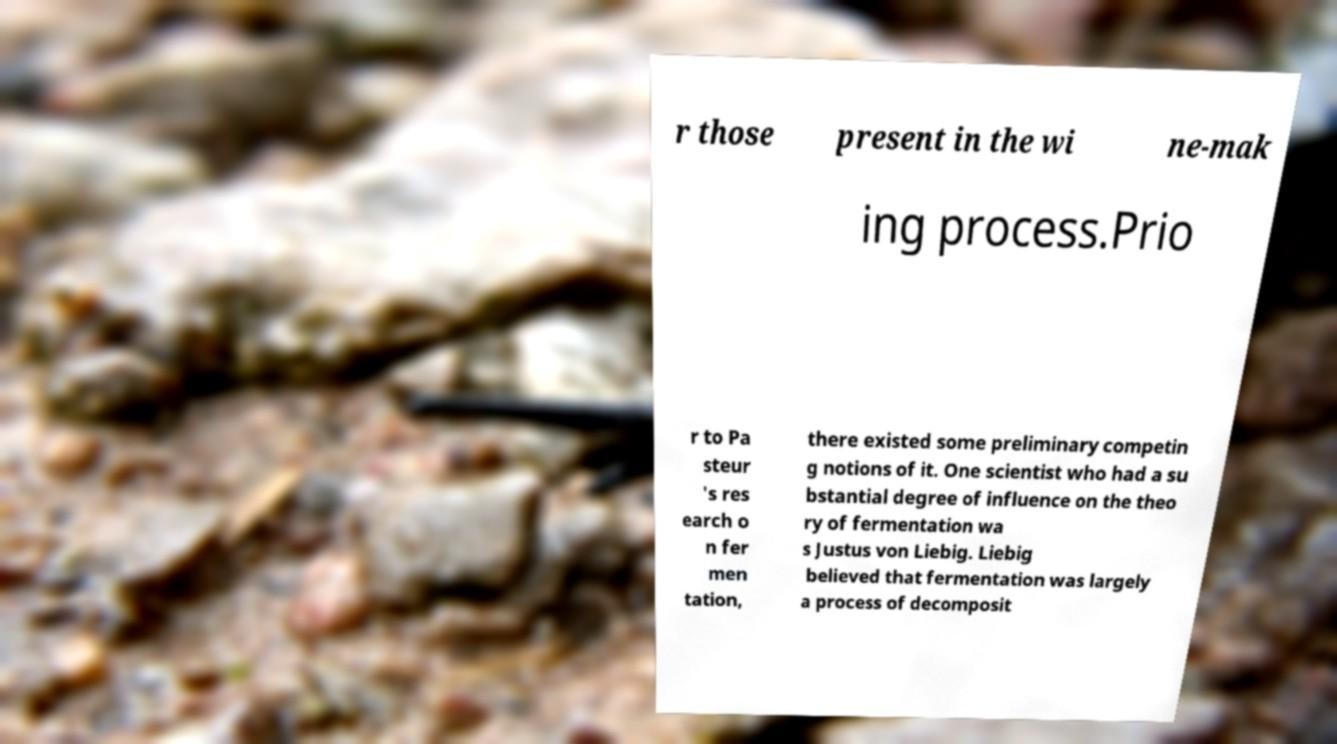There's text embedded in this image that I need extracted. Can you transcribe it verbatim? r those present in the wi ne-mak ing process.Prio r to Pa steur 's res earch o n fer men tation, there existed some preliminary competin g notions of it. One scientist who had a su bstantial degree of influence on the theo ry of fermentation wa s Justus von Liebig. Liebig believed that fermentation was largely a process of decomposit 